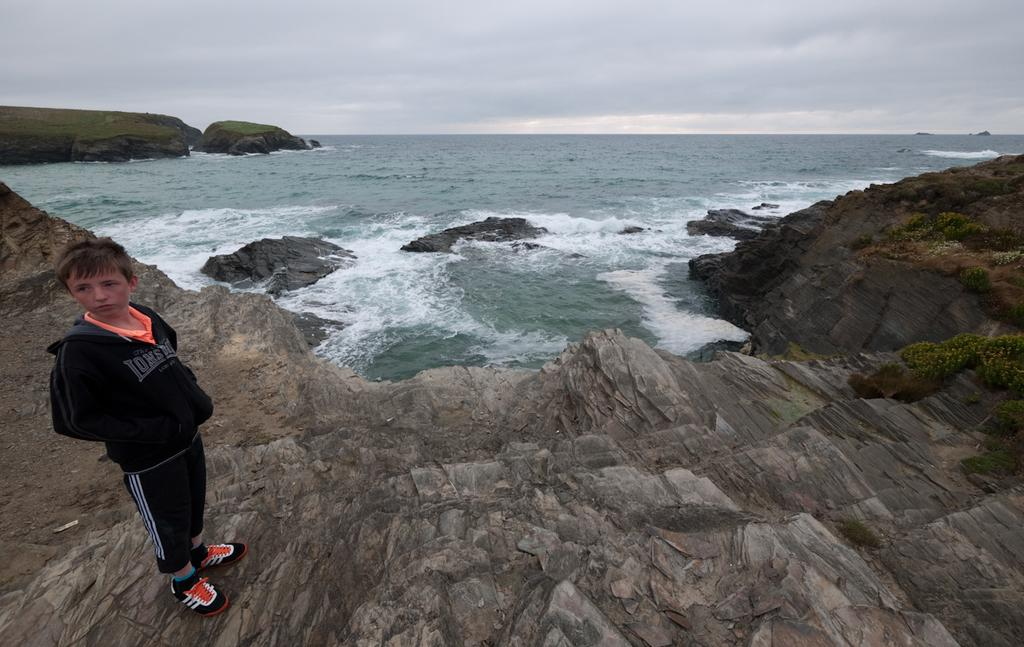What is the main subject on the left side of the image? There is a boy standing on the left side of the image. What can be seen in the background of the image? There is water visible in the background of the image. What is located at the bottom of the image? There is a rock at the bottom of the image. What type of instrument is the boy playing in the image? There is no instrument present in the image; the boy is simply standing on the left side. 